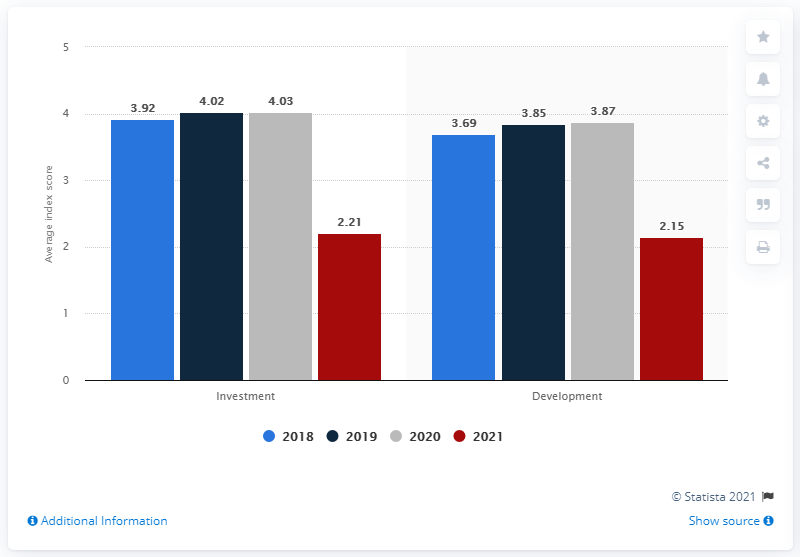Indicate a few pertinent items in this graphic. The value indicated by the grey bar in investment is 4.03. The difference between the sum of all investments and development is 0.65. 